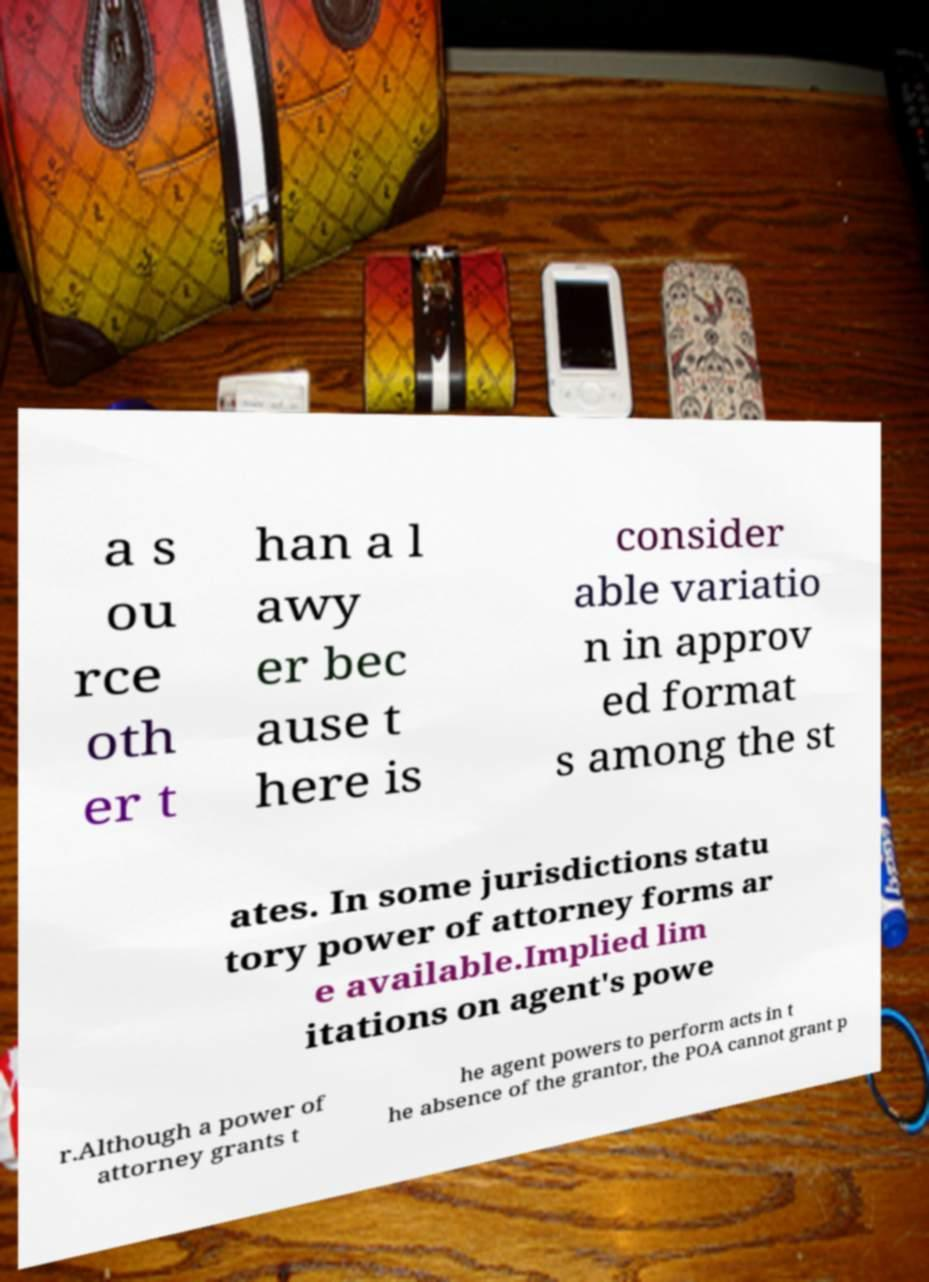Can you accurately transcribe the text from the provided image for me? a s ou rce oth er t han a l awy er bec ause t here is consider able variatio n in approv ed format s among the st ates. In some jurisdictions statu tory power of attorney forms ar e available.Implied lim itations on agent's powe r.Although a power of attorney grants t he agent powers to perform acts in t he absence of the grantor, the POA cannot grant p 